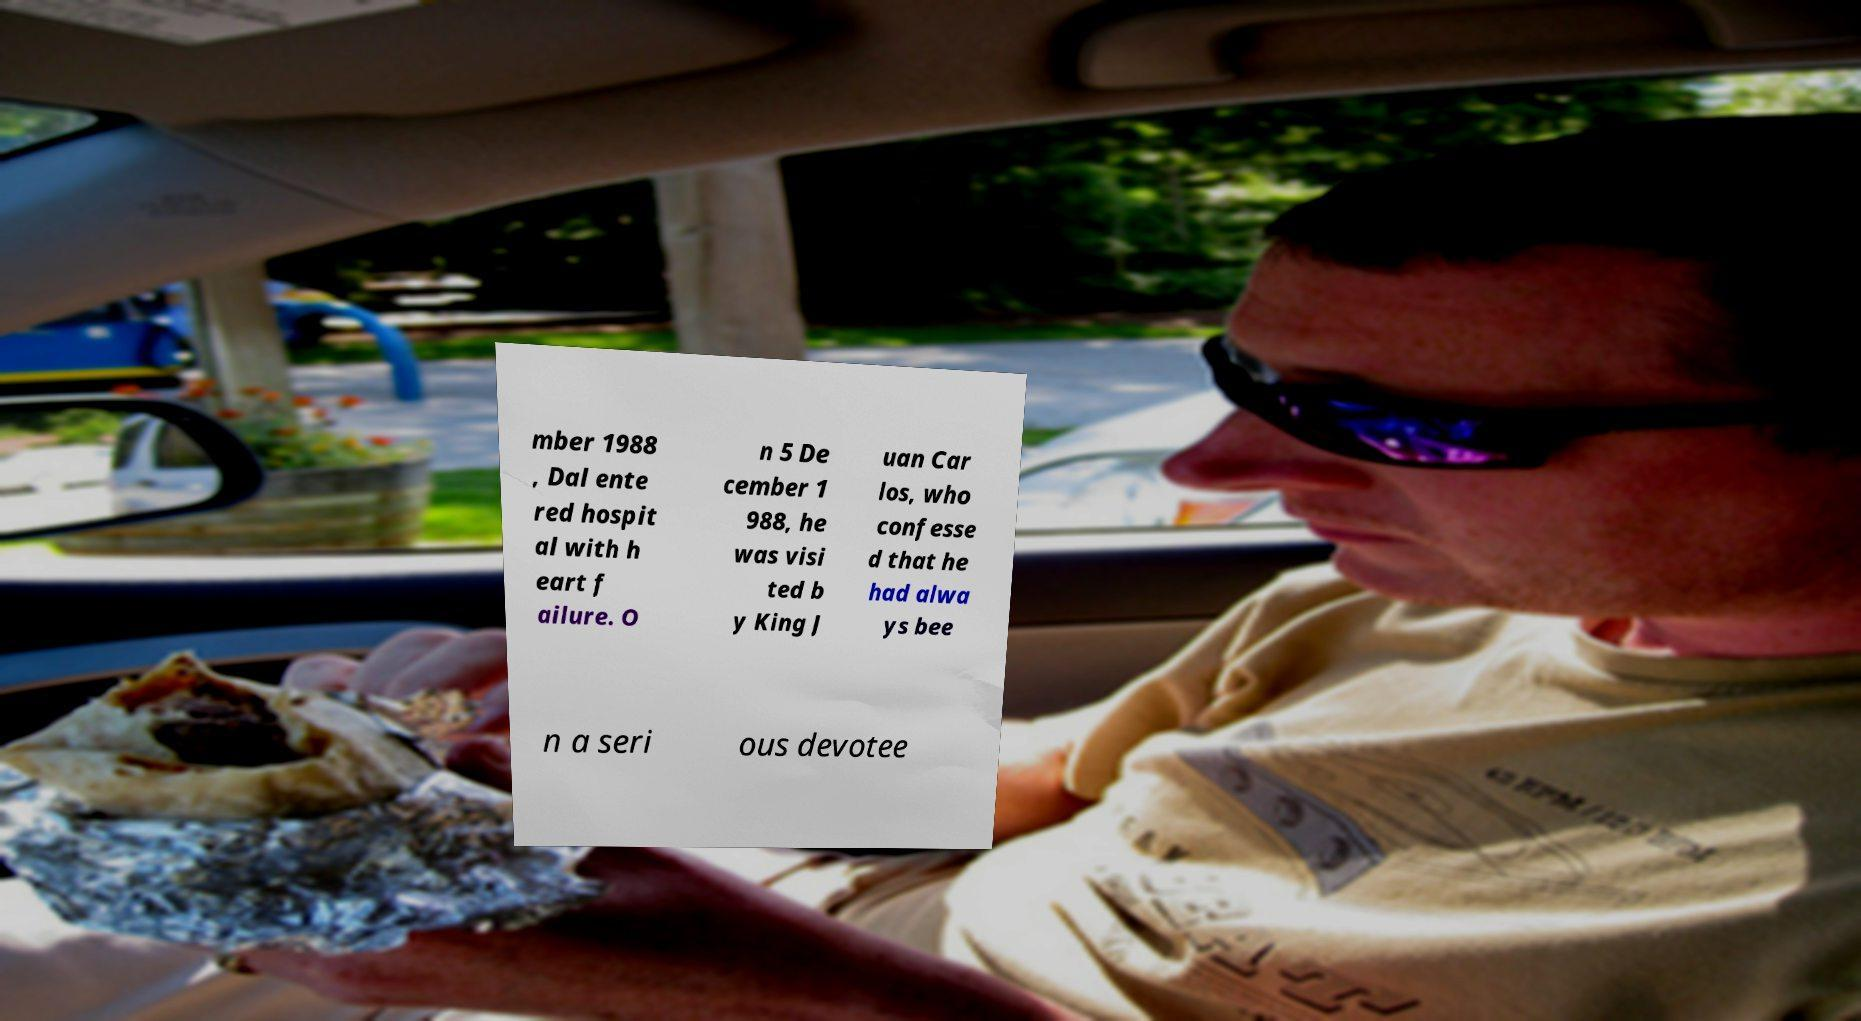There's text embedded in this image that I need extracted. Can you transcribe it verbatim? mber 1988 , Dal ente red hospit al with h eart f ailure. O n 5 De cember 1 988, he was visi ted b y King J uan Car los, who confesse d that he had alwa ys bee n a seri ous devotee 